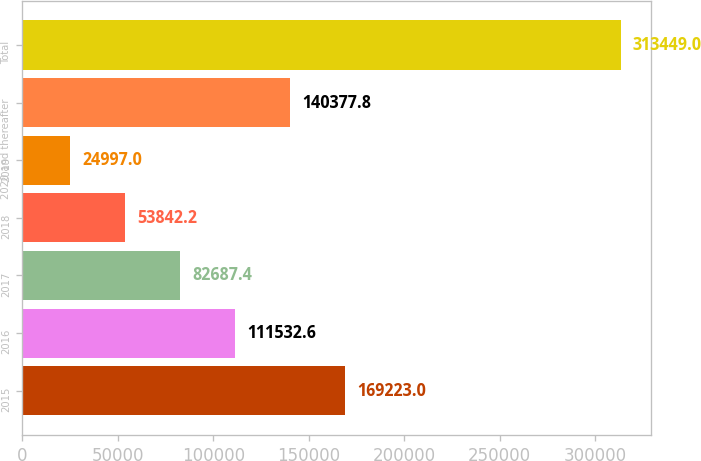<chart> <loc_0><loc_0><loc_500><loc_500><bar_chart><fcel>2015<fcel>2016<fcel>2017<fcel>2018<fcel>2019<fcel>2020 and thereafter<fcel>Total<nl><fcel>169223<fcel>111533<fcel>82687.4<fcel>53842.2<fcel>24997<fcel>140378<fcel>313449<nl></chart> 